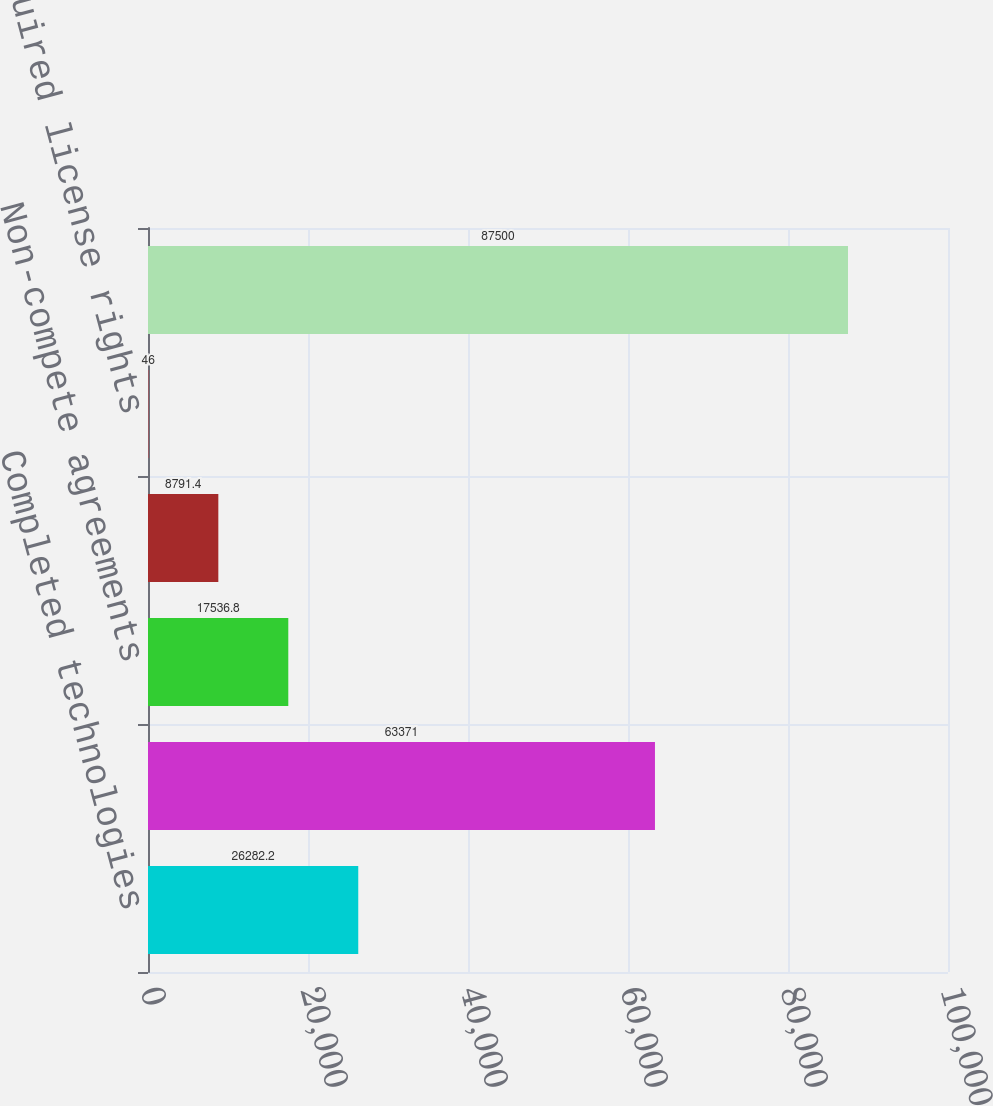<chart> <loc_0><loc_0><loc_500><loc_500><bar_chart><fcel>Completed technologies<fcel>Customer relationships<fcel>Non-compete agreements<fcel>Trademarks<fcel>Acquired license rights<fcel>Total<nl><fcel>26282.2<fcel>63371<fcel>17536.8<fcel>8791.4<fcel>46<fcel>87500<nl></chart> 